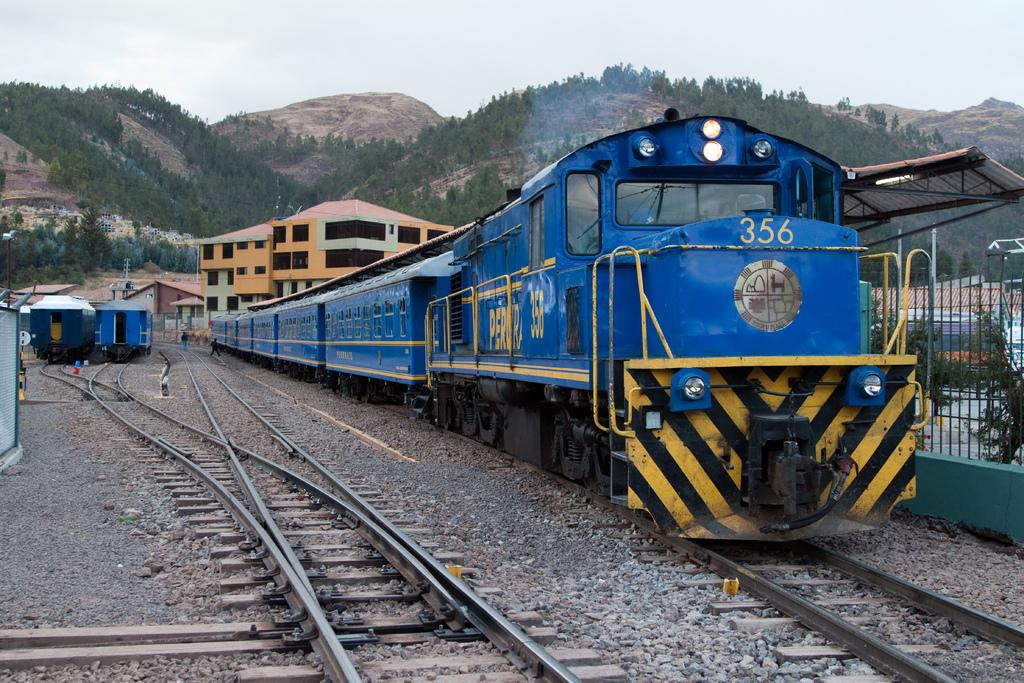<image>
Give a short and clear explanation of the subsequent image. A blue train sitting on the tracks says 356 on the front and the side. 